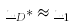Convert formula to latex. <formula><loc_0><loc_0><loc_500><loc_500>\underline { u } _ { D } * \approx \underline { u } _ { 1 }</formula> 